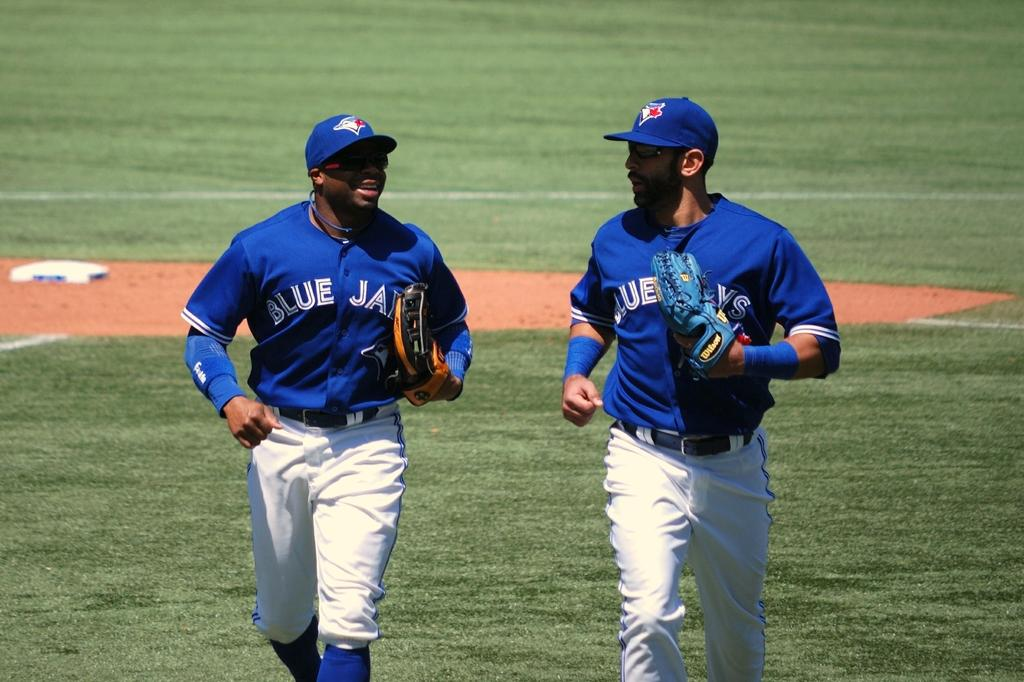<image>
Give a short and clear explanation of the subsequent image. Two men in Blue Jays baseball uniforms are on a baseball field. 